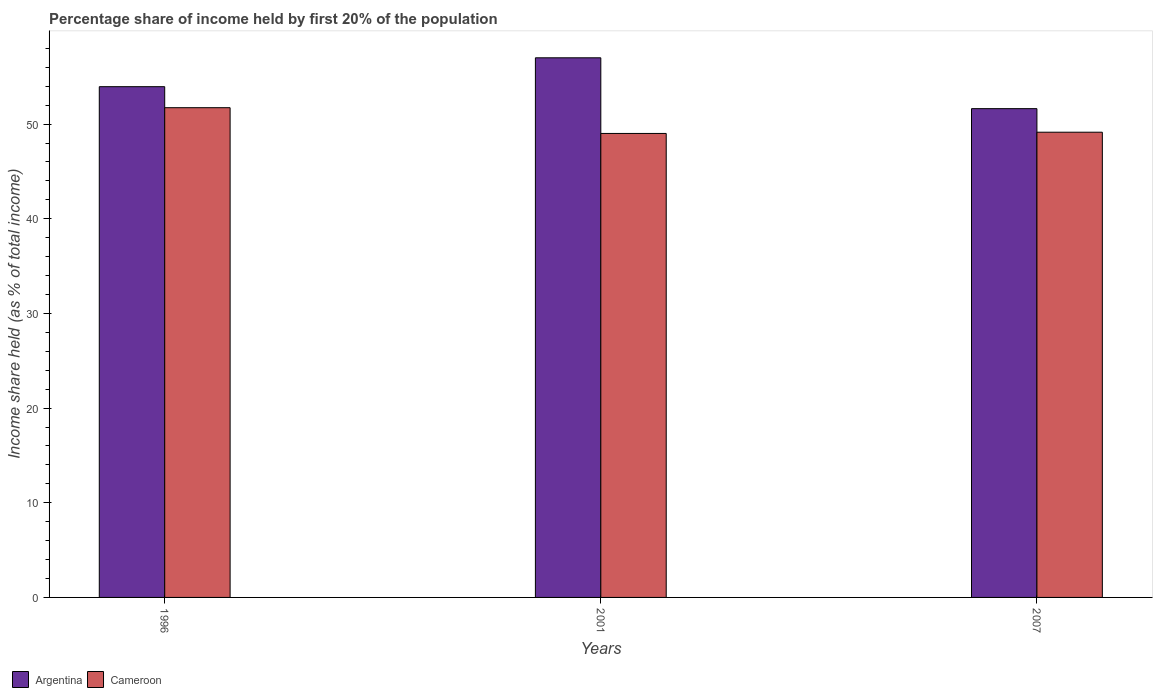How many different coloured bars are there?
Ensure brevity in your answer.  2. How many groups of bars are there?
Provide a succinct answer. 3. Are the number of bars per tick equal to the number of legend labels?
Ensure brevity in your answer.  Yes. Are the number of bars on each tick of the X-axis equal?
Offer a terse response. Yes. How many bars are there on the 3rd tick from the right?
Give a very brief answer. 2. What is the label of the 1st group of bars from the left?
Keep it short and to the point. 1996. In how many cases, is the number of bars for a given year not equal to the number of legend labels?
Provide a short and direct response. 0. Across all years, what is the minimum share of income held by first 20% of the population in Cameroon?
Your response must be concise. 49.01. What is the total share of income held by first 20% of the population in Cameroon in the graph?
Offer a very short reply. 149.88. What is the difference between the share of income held by first 20% of the population in Argentina in 1996 and that in 2001?
Keep it short and to the point. -3.05. What is the difference between the share of income held by first 20% of the population in Cameroon in 2001 and the share of income held by first 20% of the population in Argentina in 1996?
Offer a very short reply. -4.94. What is the average share of income held by first 20% of the population in Cameroon per year?
Provide a short and direct response. 49.96. In the year 2007, what is the difference between the share of income held by first 20% of the population in Cameroon and share of income held by first 20% of the population in Argentina?
Offer a terse response. -2.49. In how many years, is the share of income held by first 20% of the population in Cameroon greater than 34 %?
Your response must be concise. 3. What is the ratio of the share of income held by first 20% of the population in Argentina in 1996 to that in 2007?
Ensure brevity in your answer.  1.04. Is the share of income held by first 20% of the population in Argentina in 1996 less than that in 2007?
Your answer should be very brief. No. Is the difference between the share of income held by first 20% of the population in Cameroon in 2001 and 2007 greater than the difference between the share of income held by first 20% of the population in Argentina in 2001 and 2007?
Keep it short and to the point. No. What is the difference between the highest and the second highest share of income held by first 20% of the population in Argentina?
Your answer should be compact. 3.05. What is the difference between the highest and the lowest share of income held by first 20% of the population in Cameroon?
Provide a succinct answer. 2.72. Is the sum of the share of income held by first 20% of the population in Cameroon in 2001 and 2007 greater than the maximum share of income held by first 20% of the population in Argentina across all years?
Your answer should be very brief. Yes. How many bars are there?
Provide a succinct answer. 6. How many years are there in the graph?
Provide a short and direct response. 3. Are the values on the major ticks of Y-axis written in scientific E-notation?
Keep it short and to the point. No. Does the graph contain grids?
Keep it short and to the point. No. Where does the legend appear in the graph?
Give a very brief answer. Bottom left. How many legend labels are there?
Offer a very short reply. 2. What is the title of the graph?
Keep it short and to the point. Percentage share of income held by first 20% of the population. What is the label or title of the Y-axis?
Your response must be concise. Income share held (as % of total income). What is the Income share held (as % of total income) in Argentina in 1996?
Make the answer very short. 53.95. What is the Income share held (as % of total income) of Cameroon in 1996?
Provide a succinct answer. 51.73. What is the Income share held (as % of total income) in Argentina in 2001?
Your response must be concise. 57. What is the Income share held (as % of total income) of Cameroon in 2001?
Offer a very short reply. 49.01. What is the Income share held (as % of total income) in Argentina in 2007?
Make the answer very short. 51.63. What is the Income share held (as % of total income) of Cameroon in 2007?
Your answer should be compact. 49.14. Across all years, what is the maximum Income share held (as % of total income) of Argentina?
Provide a succinct answer. 57. Across all years, what is the maximum Income share held (as % of total income) of Cameroon?
Your answer should be very brief. 51.73. Across all years, what is the minimum Income share held (as % of total income) in Argentina?
Your response must be concise. 51.63. Across all years, what is the minimum Income share held (as % of total income) in Cameroon?
Ensure brevity in your answer.  49.01. What is the total Income share held (as % of total income) in Argentina in the graph?
Provide a short and direct response. 162.58. What is the total Income share held (as % of total income) of Cameroon in the graph?
Offer a terse response. 149.88. What is the difference between the Income share held (as % of total income) in Argentina in 1996 and that in 2001?
Provide a short and direct response. -3.05. What is the difference between the Income share held (as % of total income) in Cameroon in 1996 and that in 2001?
Your answer should be very brief. 2.72. What is the difference between the Income share held (as % of total income) in Argentina in 1996 and that in 2007?
Provide a short and direct response. 2.32. What is the difference between the Income share held (as % of total income) in Cameroon in 1996 and that in 2007?
Give a very brief answer. 2.59. What is the difference between the Income share held (as % of total income) of Argentina in 2001 and that in 2007?
Keep it short and to the point. 5.37. What is the difference between the Income share held (as % of total income) in Cameroon in 2001 and that in 2007?
Make the answer very short. -0.13. What is the difference between the Income share held (as % of total income) of Argentina in 1996 and the Income share held (as % of total income) of Cameroon in 2001?
Provide a short and direct response. 4.94. What is the difference between the Income share held (as % of total income) of Argentina in 1996 and the Income share held (as % of total income) of Cameroon in 2007?
Provide a succinct answer. 4.81. What is the difference between the Income share held (as % of total income) in Argentina in 2001 and the Income share held (as % of total income) in Cameroon in 2007?
Your answer should be compact. 7.86. What is the average Income share held (as % of total income) of Argentina per year?
Keep it short and to the point. 54.19. What is the average Income share held (as % of total income) in Cameroon per year?
Ensure brevity in your answer.  49.96. In the year 1996, what is the difference between the Income share held (as % of total income) of Argentina and Income share held (as % of total income) of Cameroon?
Keep it short and to the point. 2.22. In the year 2001, what is the difference between the Income share held (as % of total income) of Argentina and Income share held (as % of total income) of Cameroon?
Provide a succinct answer. 7.99. In the year 2007, what is the difference between the Income share held (as % of total income) in Argentina and Income share held (as % of total income) in Cameroon?
Ensure brevity in your answer.  2.49. What is the ratio of the Income share held (as % of total income) in Argentina in 1996 to that in 2001?
Offer a very short reply. 0.95. What is the ratio of the Income share held (as % of total income) in Cameroon in 1996 to that in 2001?
Offer a terse response. 1.06. What is the ratio of the Income share held (as % of total income) in Argentina in 1996 to that in 2007?
Make the answer very short. 1.04. What is the ratio of the Income share held (as % of total income) in Cameroon in 1996 to that in 2007?
Give a very brief answer. 1.05. What is the ratio of the Income share held (as % of total income) in Argentina in 2001 to that in 2007?
Make the answer very short. 1.1. What is the ratio of the Income share held (as % of total income) in Cameroon in 2001 to that in 2007?
Give a very brief answer. 1. What is the difference between the highest and the second highest Income share held (as % of total income) in Argentina?
Make the answer very short. 3.05. What is the difference between the highest and the second highest Income share held (as % of total income) of Cameroon?
Offer a very short reply. 2.59. What is the difference between the highest and the lowest Income share held (as % of total income) in Argentina?
Offer a terse response. 5.37. What is the difference between the highest and the lowest Income share held (as % of total income) of Cameroon?
Your response must be concise. 2.72. 